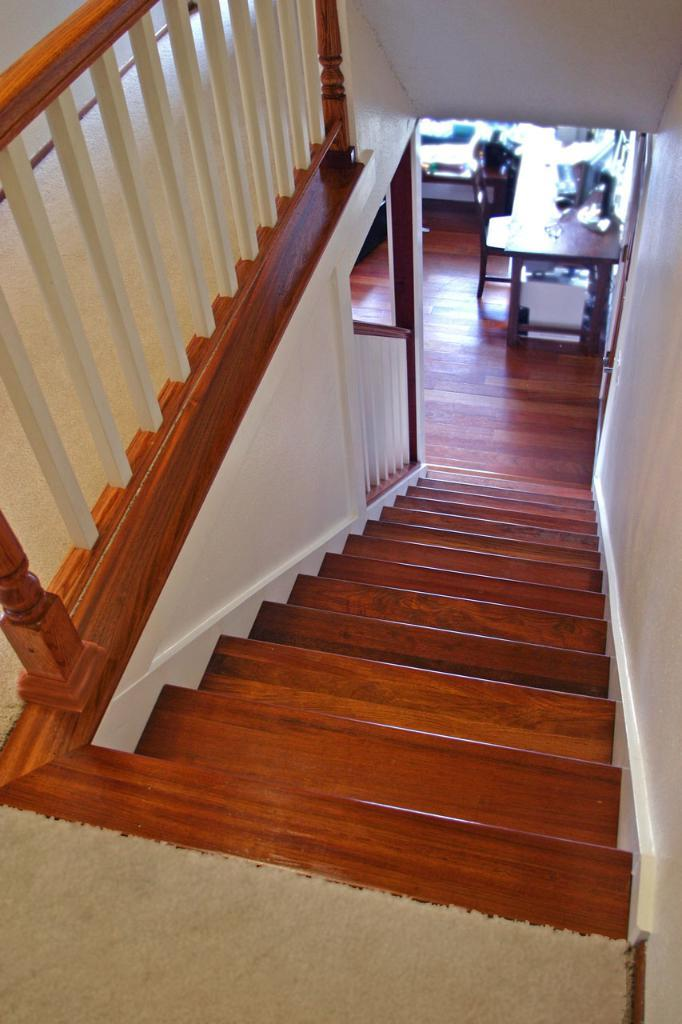What type of structure is present in the image for ascending or descending? There are stairs in the image. What type of furniture is present in the image for placing objects or serving a purpose? There is a table in the image. What type of furniture is present in the image for sitting? There is a chair in the image. What type of furniture is present in the image for sleeping or resting? There is a bed in the image. How many babies are present in the image? There are no babies present in the image. What type of room is depicted in the image? The provided facts do not specify the type of room or setting in the image. 